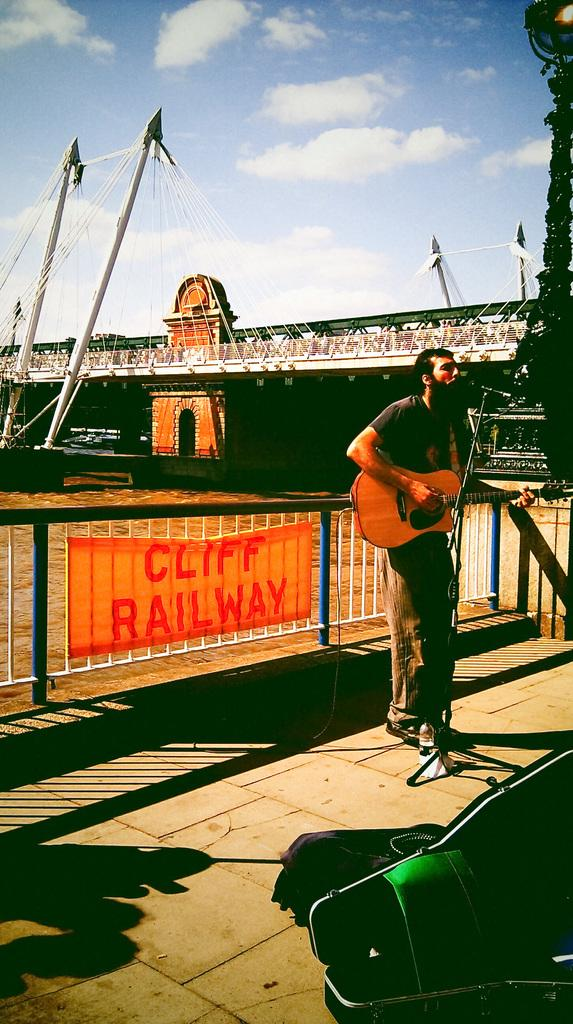What is the man in the image doing? The man is standing, playing the guitar, and singing on a microphone. What is the man holding in the image? The man is holding a guitar. What can be seen in the background of the image? There is a fence, a banner, a bridge, a pole, and the sky visible in the background of the image. What is the condition of the sky in the image? The sky is visible in the background of the image, and there are clouds present. Can you tell me how many pots are visible in the image? There are no pots present in the image. What type of sea can be seen in the background of the image? There is no sea visible in the image; it features a sky with clouds and various background elements. 